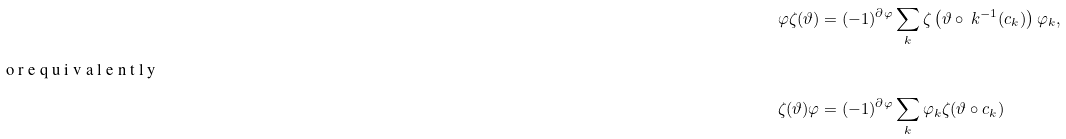<formula> <loc_0><loc_0><loc_500><loc_500>\varphi \zeta ( \vartheta ) & = ( - 1 ) ^ { \partial \varphi } \sum _ { k } \zeta \left ( \vartheta \circ \ k ^ { - 1 } ( c _ { k } ) \right ) \varphi _ { k } , \\ \intertext { o r e q u i v a l e n t l y } \zeta ( \vartheta ) \varphi & = ( - 1 ) ^ { \partial \varphi } \sum _ { k } \varphi _ { k } \zeta ( \vartheta \circ c _ { k } )</formula> 